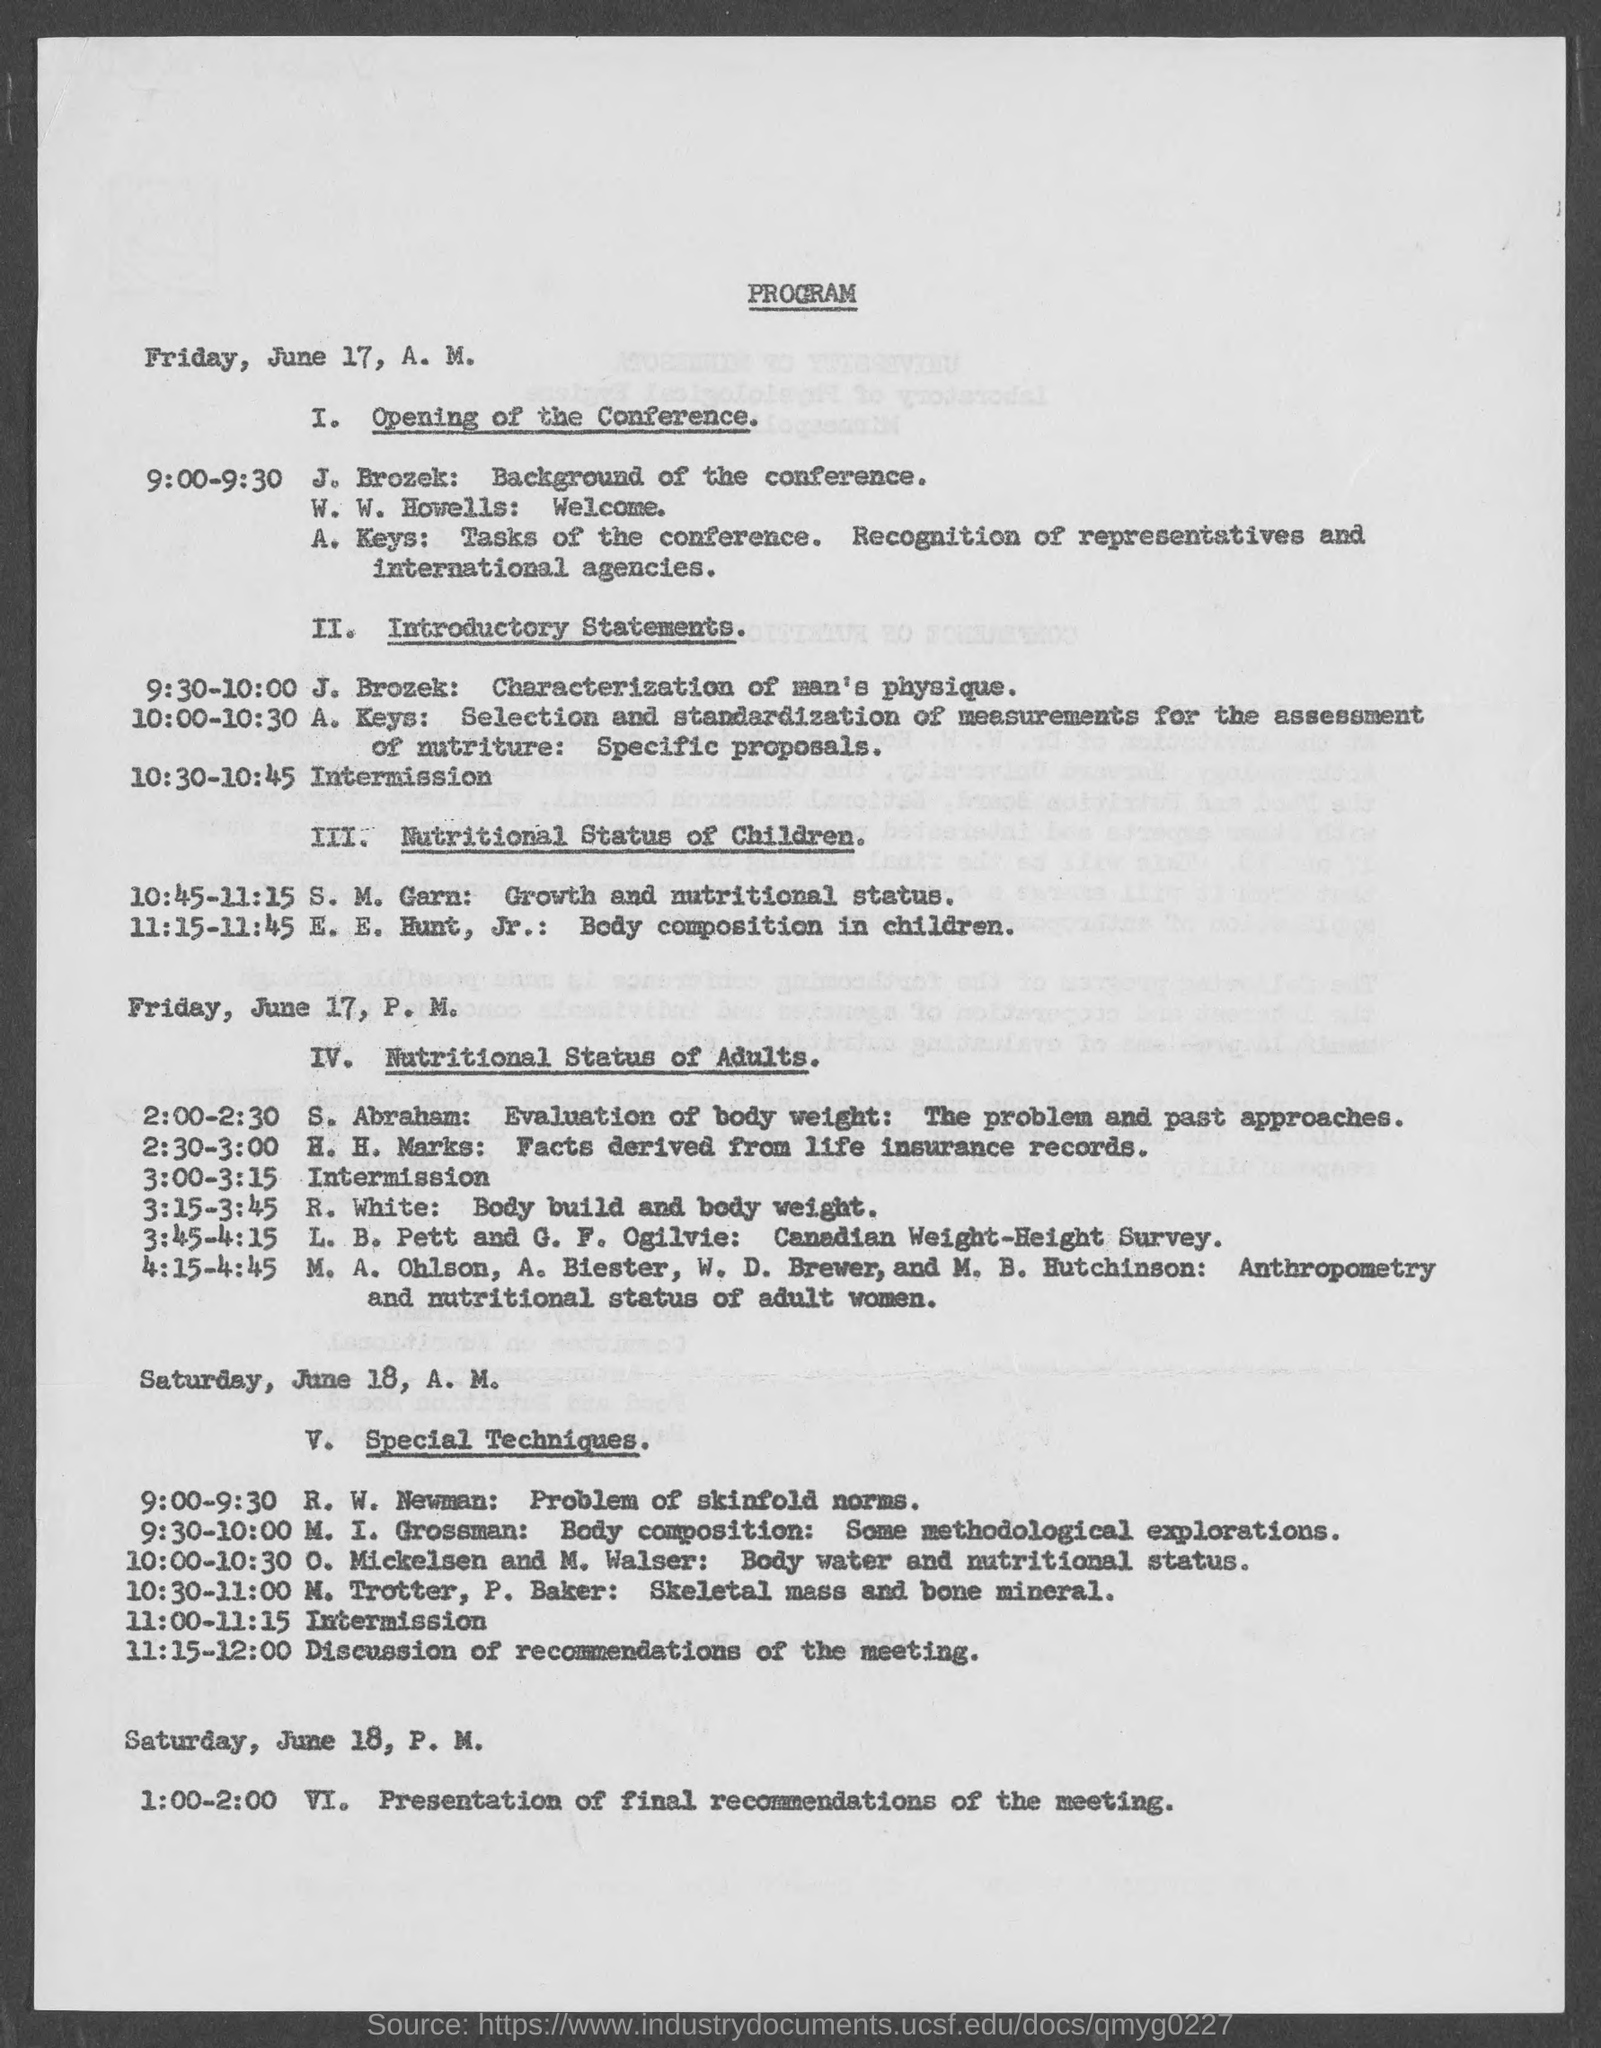Outline some significant characteristics in this image. J. Brozek's topic from 9:30-10:00 was the characterization of man's physique, which involved the study of the physical attributes of human beings. 